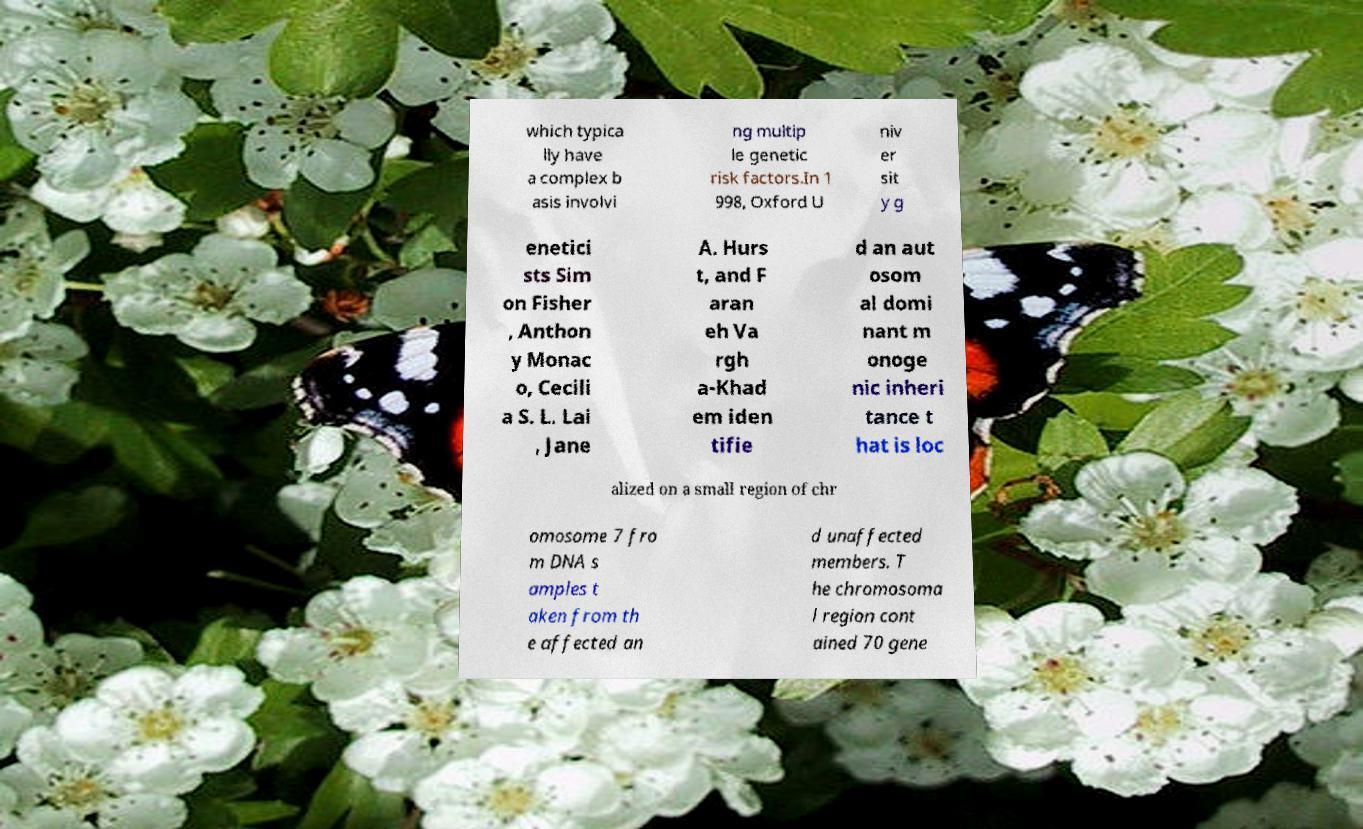Can you accurately transcribe the text from the provided image for me? which typica lly have a complex b asis involvi ng multip le genetic risk factors.In 1 998, Oxford U niv er sit y g enetici sts Sim on Fisher , Anthon y Monac o, Cecili a S. L. Lai , Jane A. Hurs t, and F aran eh Va rgh a-Khad em iden tifie d an aut osom al domi nant m onoge nic inheri tance t hat is loc alized on a small region of chr omosome 7 fro m DNA s amples t aken from th e affected an d unaffected members. T he chromosoma l region cont ained 70 gene 